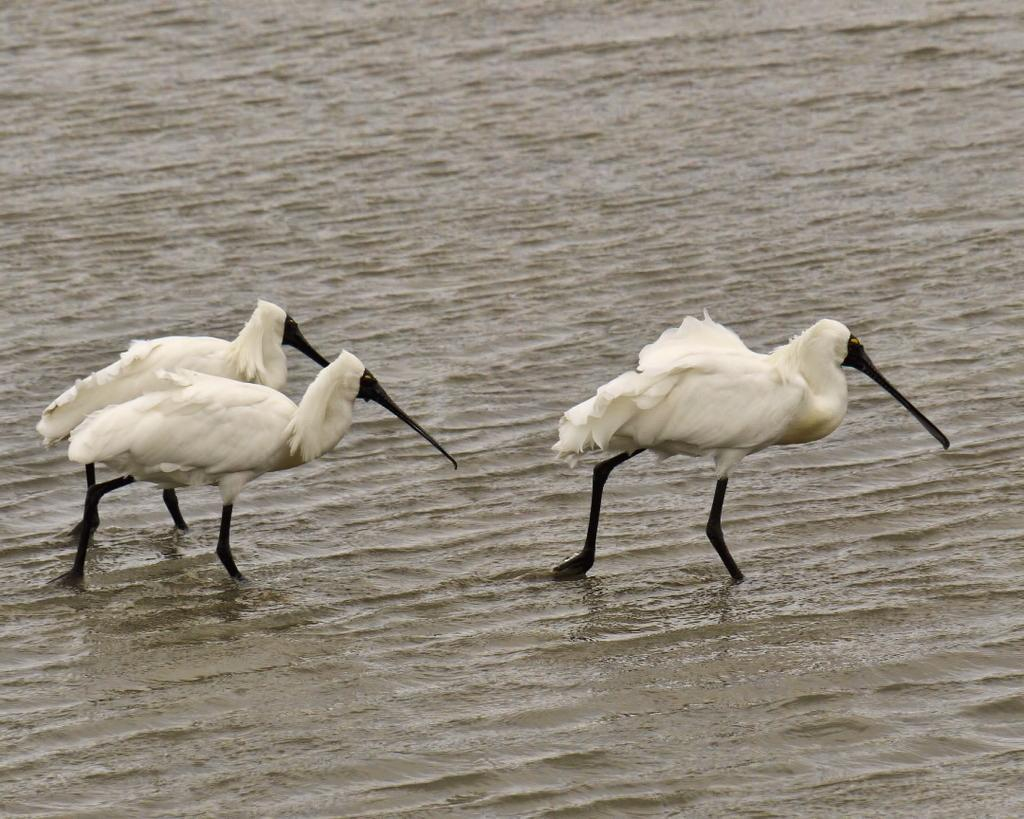What type of animals can be seen in the image? There are birds in the image. Where are the birds located in the image? The birds are on the surface of the water. What type of lizards can be seen swimming underwater in the image? There are no lizards present in the image, and the birds are on the surface of the water, not swimming underwater. What creature is boiling water in the kettle in the image? There is no kettle or creature boiling water in the image; it only features birds on the surface of the water. 